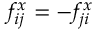Convert formula to latex. <formula><loc_0><loc_0><loc_500><loc_500>f _ { i j } ^ { x } = - f _ { j i } ^ { x }</formula> 